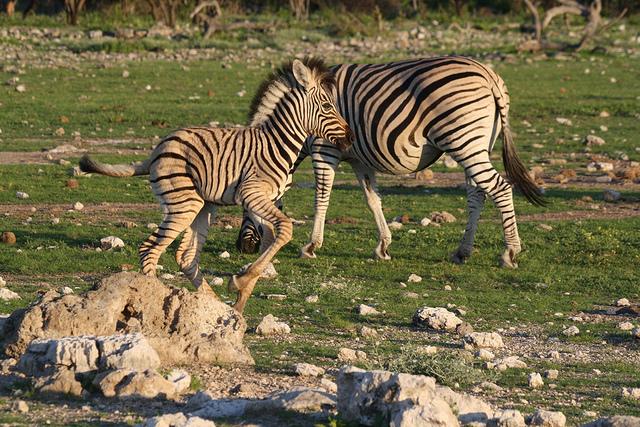What is this animal?
Give a very brief answer. Zebra. How many zebras are in the picture?
Write a very short answer. 2. Is the smaller animal running?
Answer briefly. Yes. How many animals are there?
Give a very brief answer. 2. 